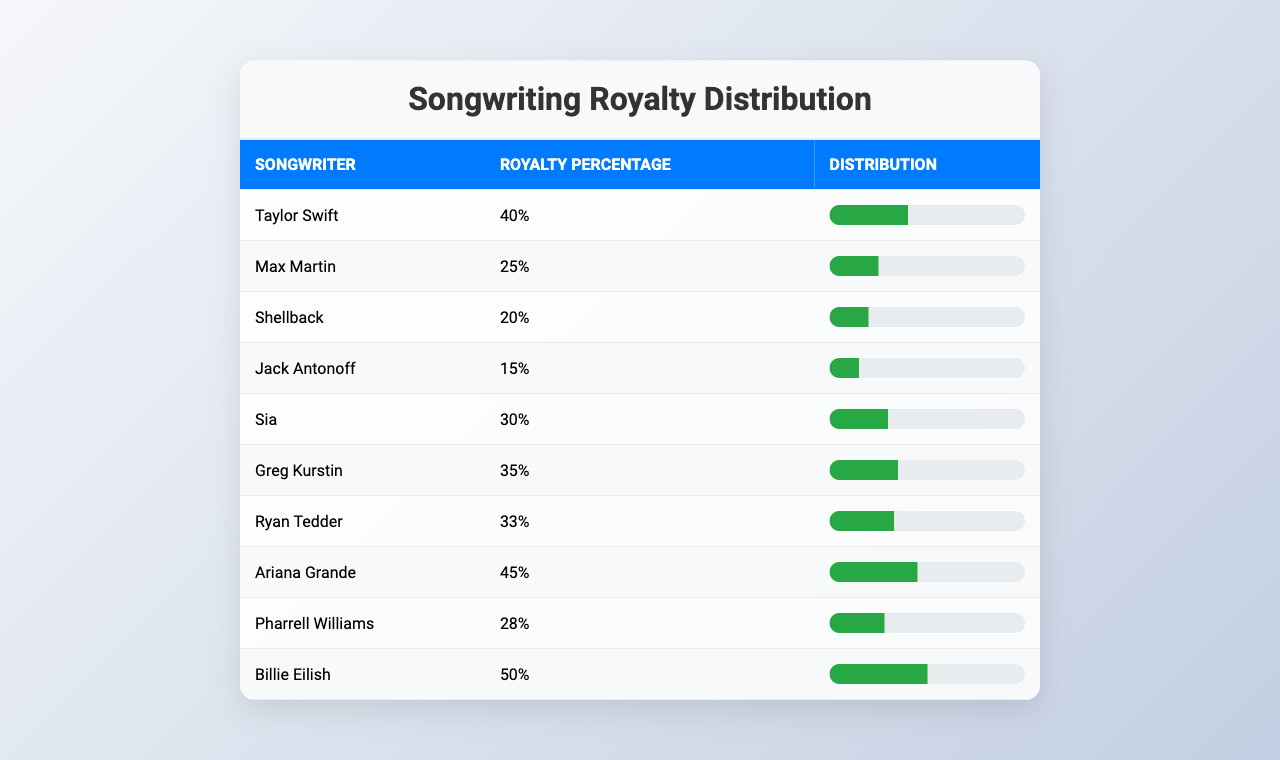What is the highest royalty percentage listed in the table? The highest royalty percentage can be found by scanning through the percentages in the table. Billie Eilish has the highest percentage at 50%.
Answer: 50% Who has a higher royalty percentage, Max Martin or Shellback? By comparing the royalty percentages of Max Martin (25%) and Shellback (20%) in the table, it's clear that Max Martin has the higher percentage.
Answer: Max Martin What is the total royalty percentage of the first three songwriters? To calculate the total, we sum the percentages of the first three songwriters: Taylor Swift (40%) + Max Martin (25%) + Shellback (20%) = 85%.
Answer: 85% Is Ariana Grande's royalty percentage greater than 40%? By looking at Ariana Grande's royalty percentage (45%) in the table, we can see that it is indeed greater than 40%.
Answer: Yes Which songwriter has a royalty percentage closest to the average of the percentages? First, we need to calculate the average percentage. The total percentage is 40 + 25 + 20 + 15 + 30 + 35 + 33 + 45 + 28 + 50 = 378, and there are 10 songwriters, so the average is 378/10 = 37.8%. The closest percentage is Greg Kurstin at 35%.
Answer: Greg Kurstin Is it true that none of the songwriters have a royalty percentage below 20%? By reviewing the table, we see that Shellback has a royalty percentage of 20%, which means there is at least one songwriter at this threshold, so the statement is false.
Answer: No Which songwriter has a royalty percentage that is more than the combined percentages of Sia and Jack Antonoff? First, we calculate Sia's (30%) and Jack Antonoff's (15%) percentages together: 30% + 15% = 45%. Now we check each songwriter; Ariana Grande at 45% does not exceed this total, but Pharrell Williams at 28% does. Considering all songwriters, no one exceeds the total, indicating only one matches it.
Answer: None What is the difference between the highest and lowest royalty percentages? The highest percentage is observed with Billie Eilish at 50% and the lowest with Shellback at 20%. The difference is calculated as 50% - 20% = 30%.
Answer: 30% 